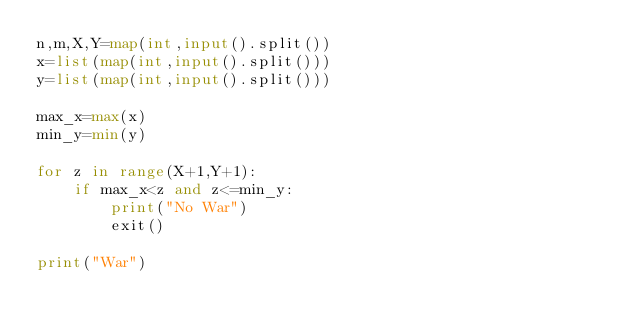Convert code to text. <code><loc_0><loc_0><loc_500><loc_500><_Python_>n,m,X,Y=map(int,input().split())
x=list(map(int,input().split()))
y=list(map(int,input().split()))

max_x=max(x)
min_y=min(y)

for z in range(X+1,Y+1):
    if max_x<z and z<=min_y:
        print("No War")
        exit()

print("War")
</code> 